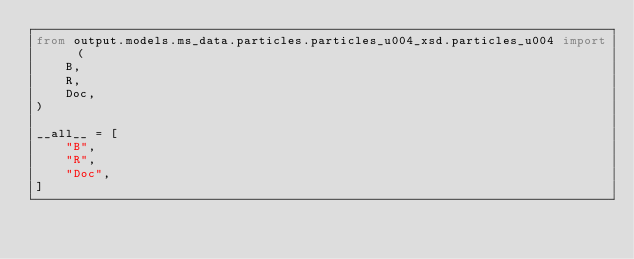Convert code to text. <code><loc_0><loc_0><loc_500><loc_500><_Python_>from output.models.ms_data.particles.particles_u004_xsd.particles_u004 import (
    B,
    R,
    Doc,
)

__all__ = [
    "B",
    "R",
    "Doc",
]
</code> 